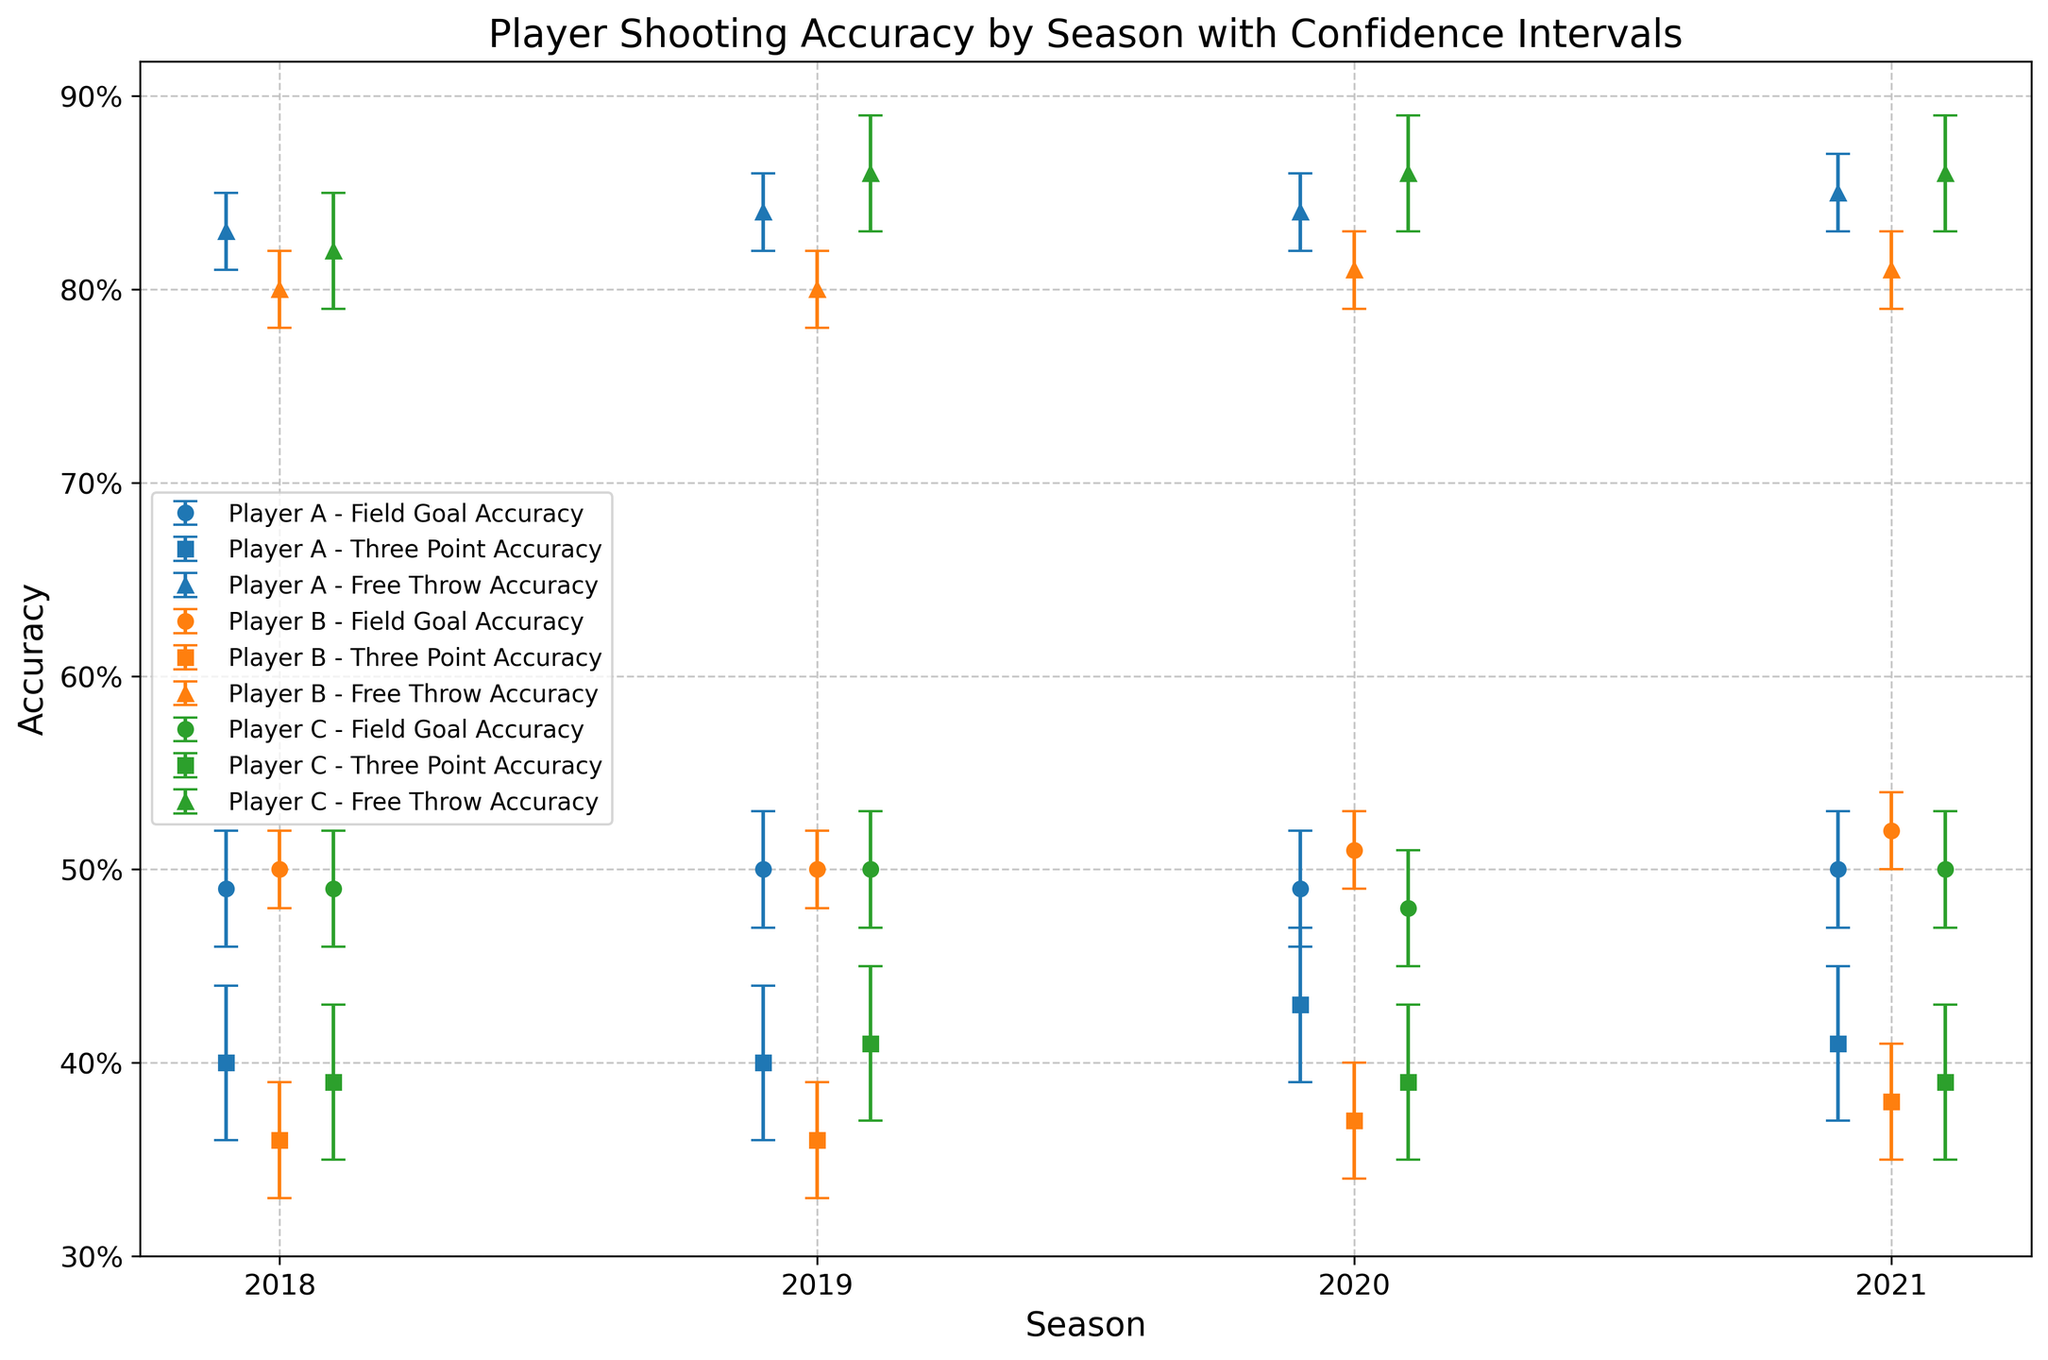What is the highest Free Throw Accuracy achieved by Player A across all seasons? To determine the highest Free Throw Accuracy for Player A, look at the vertical positions of the symbols corresponding to Free Throw Accuracy (marked differently for each type of shot) for Player A (blue). The highest value is seen in the 2021 season.
Answer: 0.85 How does Player B's Three Point Accuracy compare between the 2018 and 2020 seasons? Compare the vertical heights of the markers for Three Point Accuracy (orange colors) for Player B (second from the right) between the 2018 and 2020 seasons. The Three Point Accuracy in 2018 is 0.36, while in 2020 it is 0.37.
Answer: Higher in 2020 What is the average Field Goal Accuracy for Player C over the four seasons? To find the average Field Goal Accuracy for Player C, sum the Field Goal Accuracy values for each season and divide by the number of seasons: (0.49 + 0.50 + 0.48 + 0.50) / 4 = 1.97 / 4.
Answer: 0.4925 Which player showed the most improvement in Three Point Accuracy from 2018 to 2021? Assess the differences in Three Point Accuracy between the 2018 and 2021 seasons for each player. Compute the increase: (0.41 - 0.40) for Player A, (0.38 - 0.36) for Player B, and (0.39 - 0.39) for Player C. Player A improved by 0.01, Player B by 0.02, and Player C by 0.
Answer: Player B What is the range of Field Goal Accuracy for Player A across all seasons? To find the range, identify the highest and lowest Field Goal Accuracy for Player A and subtract the lowest from the highest. The highest value is 0.50 (2019, 2021), and the lowest is 0.49 (2018, 2020). So, the range is 0.50 - 0.49.
Answer: 0.01 Which season did Player B record the highest Field Goal Accuracy? Compare the markers for Field Goal Accuracy for Player B across seasons. The highest marker position is in 2021 with an accuracy of 0.52.
Answer: 2021 Is Player C's Free Throw Accuracy consistent across the seasons? Examine the markers for Free Throw Accuracy for Player C across all four seasons. The values are closely spaced between 0.82 and 0.86, indicating consistent performance.
Answer: Yes How does the confidence interval for Player A's Three Point Accuracy in 2020 compare to 2018? Measure the length of the error bars for Player A's Three Point Accuracy in 2020 and 2018. The error bars are similar in length in both seasons, showing a confidence interval of approximately 0.04.
Answer: Same Which player had the lowest Three Point Accuracy in 2019? Analyze the Three Point Accuracy markers for each player in 2019. Player B (orange) has the lowest Three Point Accuracy at 0.36.
Answer: Player B What is the change in Free Throw Accuracy for Player C from 2018 to 2021? Subtract Player C's Free Throw Accuracy in 2018 (0.82) from that in 2021 (0.86): 0.86 - 0.82.
Answer: 0.04 